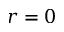Convert formula to latex. <formula><loc_0><loc_0><loc_500><loc_500>r = 0</formula> 